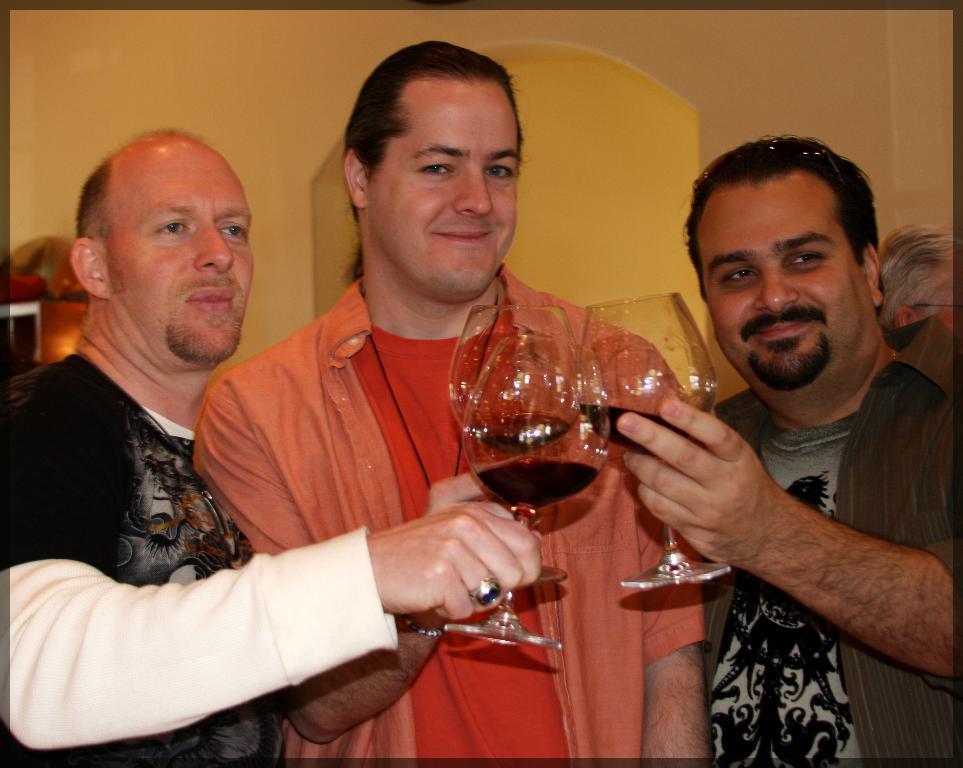Please provide a concise description of this image. In the foreground of the picture there are three people standing and holding glasses. In the background there is a wall. 